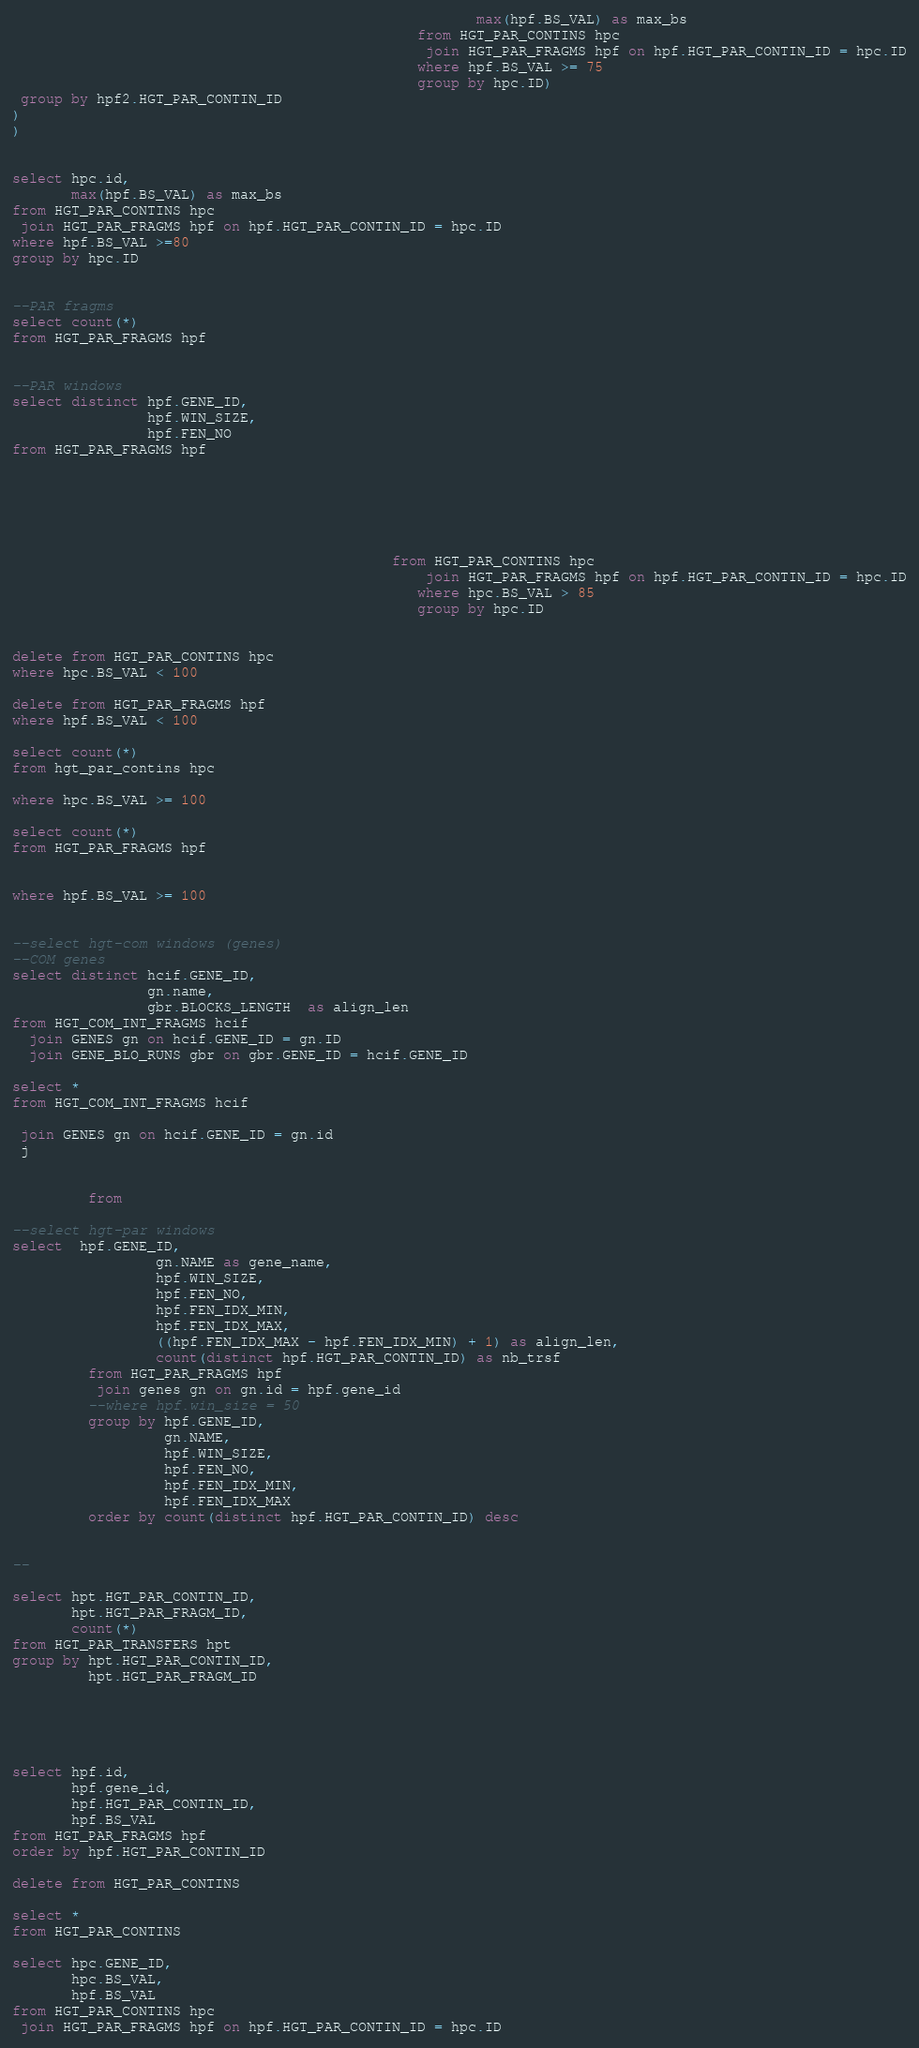Convert code to text. <code><loc_0><loc_0><loc_500><loc_500><_SQL_>                                                       max(hpf.BS_VAL) as max_bs
                                                from HGT_PAR_CONTINS hpc 
                                                 join HGT_PAR_FRAGMS hpf on hpf.HGT_PAR_CONTIN_ID = hpc.ID
                                                where hpf.BS_VAL >= 75
                                                group by hpc.ID)
 group by hpf2.HGT_PAR_CONTIN_ID
)
)              


select hpc.id,
       max(hpf.BS_VAL) as max_bs
from HGT_PAR_CONTINS hpc 
 join HGT_PAR_FRAGMS hpf on hpf.HGT_PAR_CONTIN_ID = hpc.ID
where hpf.BS_VAL >=80
group by hpc.ID
                                                

--PAR fragms
select count(*)
from HGT_PAR_FRAGMS hpf


--PAR windows
select distinct hpf.GENE_ID,
                hpf.WIN_SIZE,
                hpf.FEN_NO
from HGT_PAR_FRAGMS hpf





                                             
                                             from HGT_PAR_CONTINS hpc 
                                                 join HGT_PAR_FRAGMS hpf on hpf.HGT_PAR_CONTIN_ID = hpc.ID
                                                where hpc.BS_VAL > 85
                                                group by hpc.ID


delete from HGT_PAR_CONTINS hpc
where hpc.BS_VAL < 100

delete from HGT_PAR_FRAGMS hpf
where hpf.BS_VAL < 100

select count(*)
from hgt_par_contins hpc

where hpc.BS_VAL >= 100

select count(*)
from HGT_PAR_FRAGMS hpf


where hpf.BS_VAL >= 100


--select hgt-com windows (genes)
--COM genes 
select distinct hcif.GENE_ID,
                gn.name,
                gbr.BLOCKS_LENGTH  as align_len
from HGT_COM_INT_FRAGMS hcif
  join GENES gn on hcif.GENE_ID = gn.ID
  join GENE_BLO_RUNS gbr on gbr.GENE_ID = hcif.GENE_ID

select *
from HGT_COM_INT_FRAGMS hcif
 
 join GENES gn on hcif.GENE_ID = gn.id
 j


         from 

--select hgt-par windows
select  hpf.GENE_ID,
                 gn.NAME as gene_name,
                 hpf.WIN_SIZE,
                 hpf.FEN_NO,
                 hpf.FEN_IDX_MIN,
                 hpf.FEN_IDX_MAX,
                 ((hpf.FEN_IDX_MAX - hpf.FEN_IDX_MIN) + 1) as align_len,
                 count(distinct hpf.HGT_PAR_CONTIN_ID) as nb_trsf
         from HGT_PAR_FRAGMS hpf
          join genes gn on gn.id = hpf.gene_id
         --where hpf.win_size = 50 
         group by hpf.GENE_ID,
                  gn.NAME,
                  hpf.WIN_SIZE,
                  hpf.FEN_NO,
                  hpf.FEN_IDX_MIN,
                  hpf.FEN_IDX_MAX
         order by count(distinct hpf.HGT_PAR_CONTIN_ID) desc


--

select hpt.HGT_PAR_CONTIN_ID,
       hpt.HGT_PAR_FRAGM_ID,
       count(*)
from HGT_PAR_TRANSFERS hpt
group by hpt.HGT_PAR_CONTIN_ID,
         hpt.HGT_PAR_FRAGM_ID





select hpf.id,
       hpf.gene_id,
       hpf.HGT_PAR_CONTIN_ID,
       hpf.BS_VAL
from HGT_PAR_FRAGMS hpf
order by hpf.HGT_PAR_CONTIN_ID

delete from HGT_PAR_CONTINS

select *
from HGT_PAR_CONTINS

select hpc.GENE_ID,
       hpc.BS_VAL,
       hpf.BS_VAL
from HGT_PAR_CONTINS hpc
 join HGT_PAR_FRAGMS hpf on hpf.HGT_PAR_CONTIN_ID = hpc.ID

</code> 